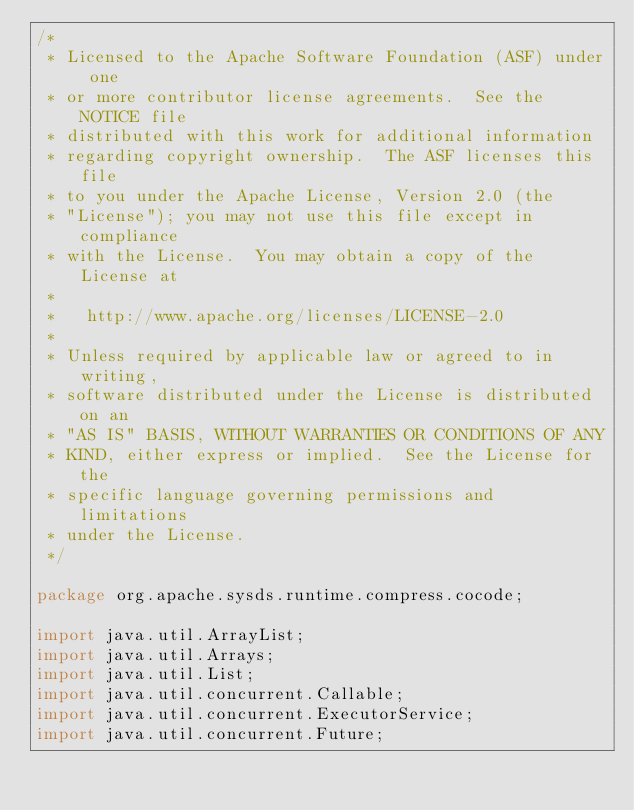Convert code to text. <code><loc_0><loc_0><loc_500><loc_500><_Java_>/*
 * Licensed to the Apache Software Foundation (ASF) under one
 * or more contributor license agreements.  See the NOTICE file
 * distributed with this work for additional information
 * regarding copyright ownership.  The ASF licenses this file
 * to you under the Apache License, Version 2.0 (the
 * "License"); you may not use this file except in compliance
 * with the License.  You may obtain a copy of the License at
 *
 *   http://www.apache.org/licenses/LICENSE-2.0
 *
 * Unless required by applicable law or agreed to in writing,
 * software distributed under the License is distributed on an
 * "AS IS" BASIS, WITHOUT WARRANTIES OR CONDITIONS OF ANY
 * KIND, either express or implied.  See the License for the
 * specific language governing permissions and limitations
 * under the License.
 */

package org.apache.sysds.runtime.compress.cocode;

import java.util.ArrayList;
import java.util.Arrays;
import java.util.List;
import java.util.concurrent.Callable;
import java.util.concurrent.ExecutorService;
import java.util.concurrent.Future;
</code> 